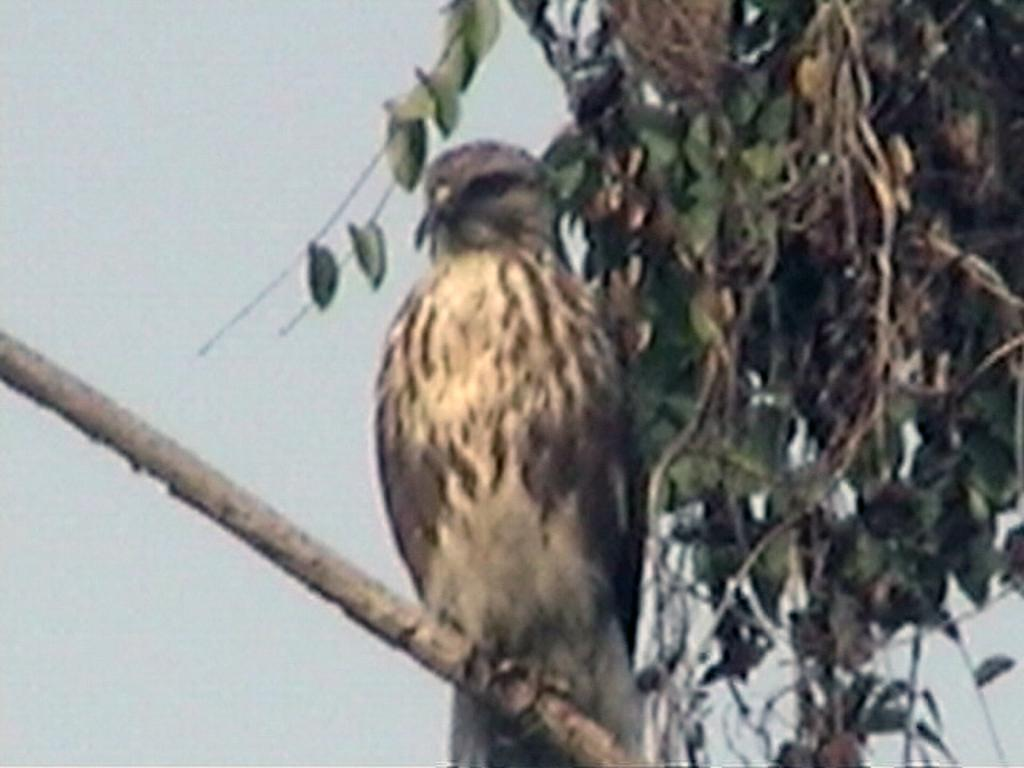What type of animal is in the image? There is a bird in the image. Where is the bird located in the image? The bird is sitting on a stem. What can be seen on the right side of the image? There are green leaves on the right side of the image. What is visible at the top of the image? The sky is visible at the top of the image. What type of drink is the bird holding in the image? There is no drink present in the image; the bird is sitting on a stem. 